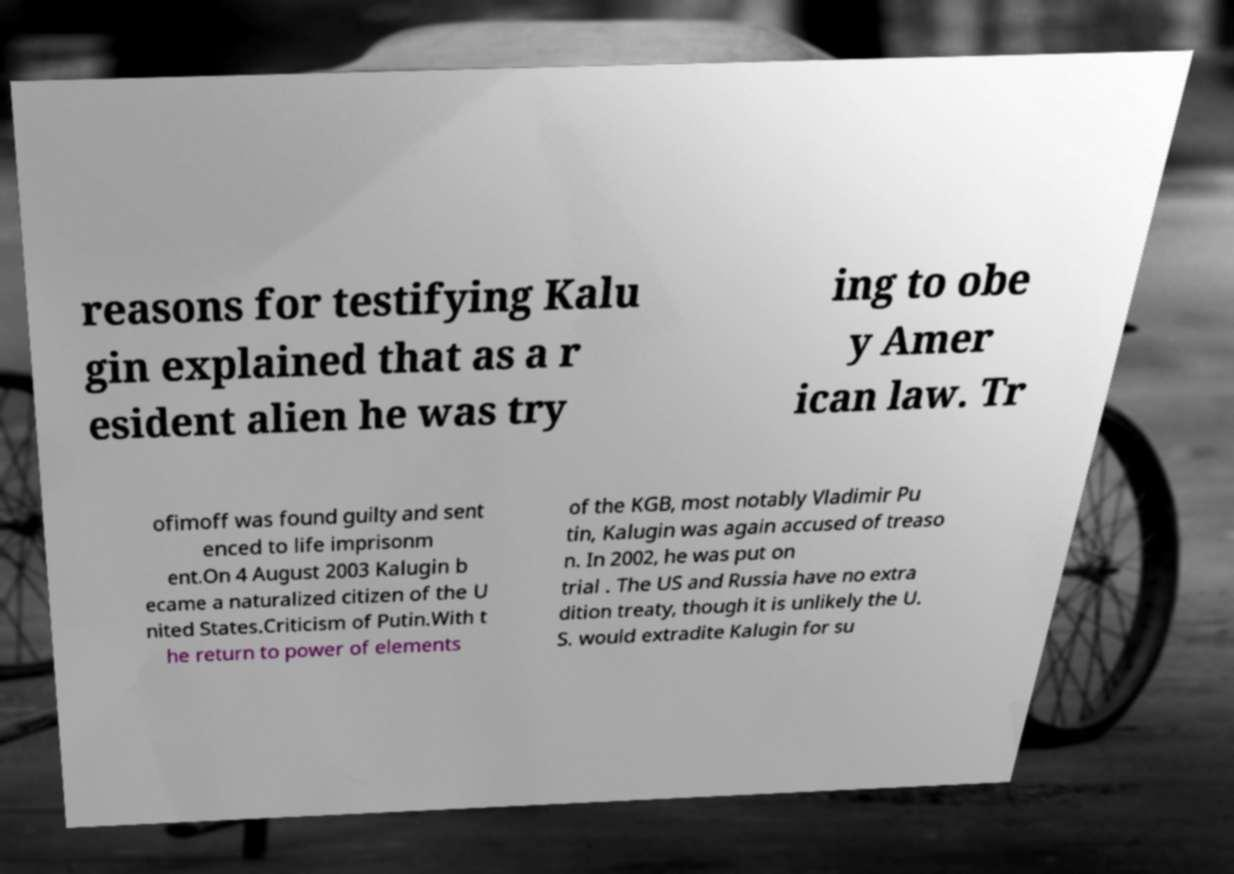I need the written content from this picture converted into text. Can you do that? reasons for testifying Kalu gin explained that as a r esident alien he was try ing to obe y Amer ican law. Tr ofimoff was found guilty and sent enced to life imprisonm ent.On 4 August 2003 Kalugin b ecame a naturalized citizen of the U nited States.Criticism of Putin.With t he return to power of elements of the KGB, most notably Vladimir Pu tin, Kalugin was again accused of treaso n. In 2002, he was put on trial . The US and Russia have no extra dition treaty, though it is unlikely the U. S. would extradite Kalugin for su 